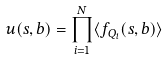<formula> <loc_0><loc_0><loc_500><loc_500>u ( s , b ) = \prod ^ { N } _ { i = 1 } \langle f _ { Q _ { i } } ( s , b ) \rangle</formula> 